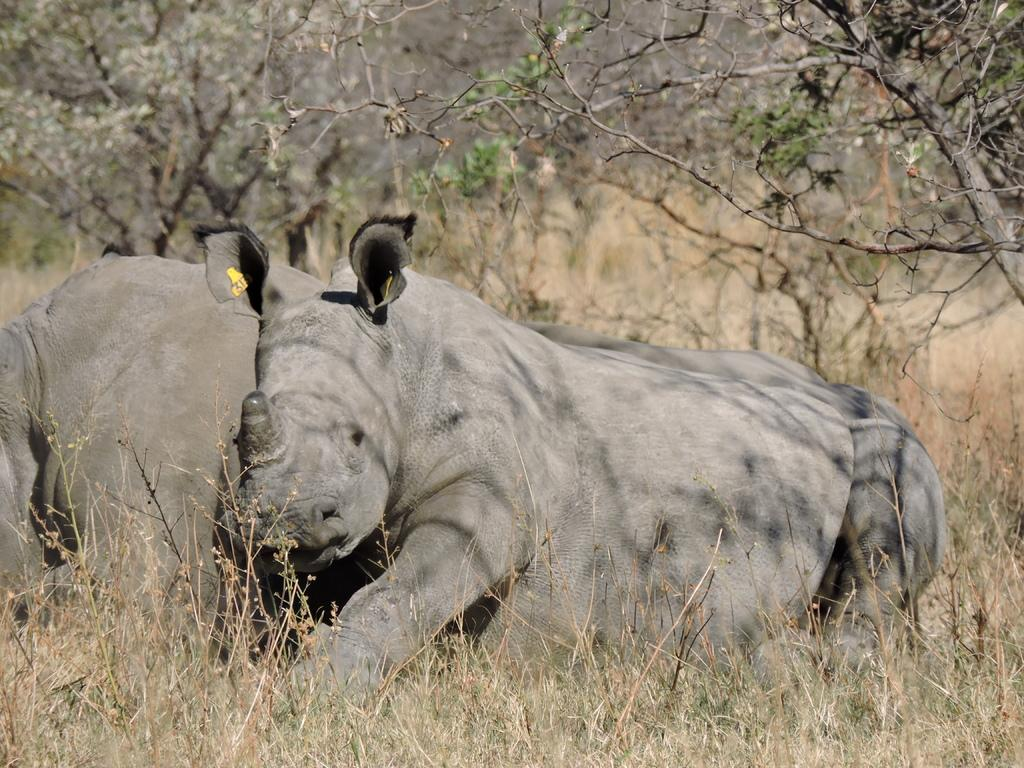What type of animals can be seen in the image? There are animals on the ground in the image. What type of vegetation is visible on the ground? There is grass visible in the image. What can be seen in the background of the image? There are trees in the background of the image. What line can be seen connecting the animals in the image? There is no line connecting the animals in the image; they are not arranged in a specific pattern or formation. 